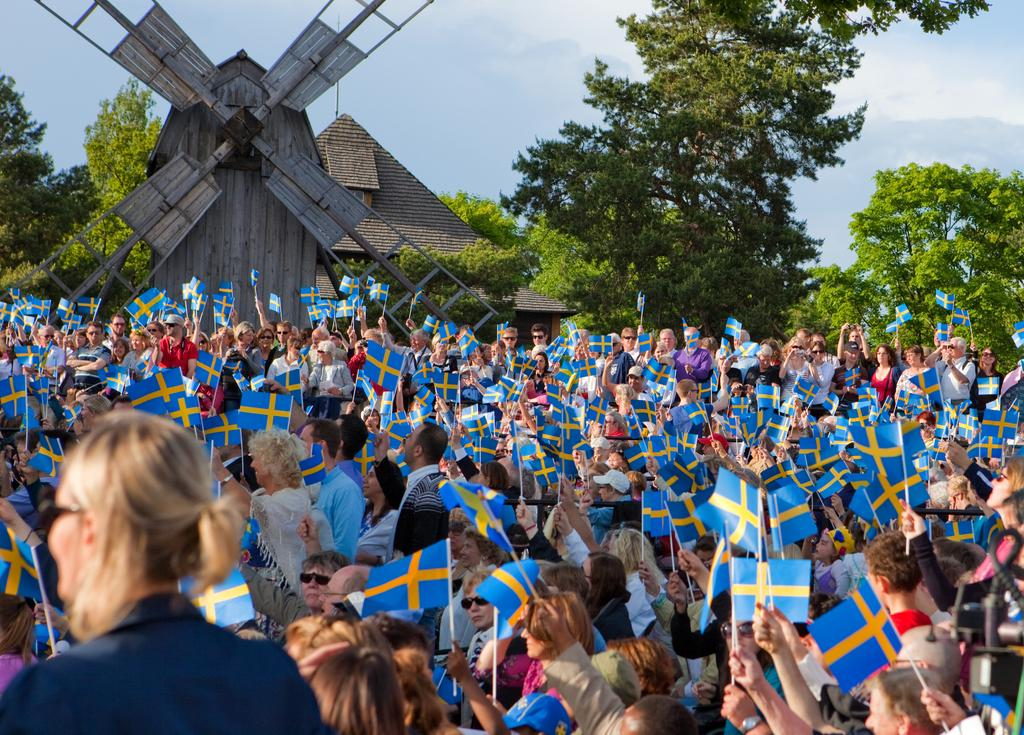What is the main subject of the image? The main subject of the image is a huge crowd. What are the people in the crowd doing? The people in the crowd are holding their country's flag. Can you describe any other objects in the image? Yes, there is a wooden fan with four wings in the image. What type of natural elements can be seen in the image? There are many trees visible in the image. What type of insect can be seen in the image? There is no insect present in the image. 